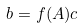<formula> <loc_0><loc_0><loc_500><loc_500>b = f ( A ) c</formula> 